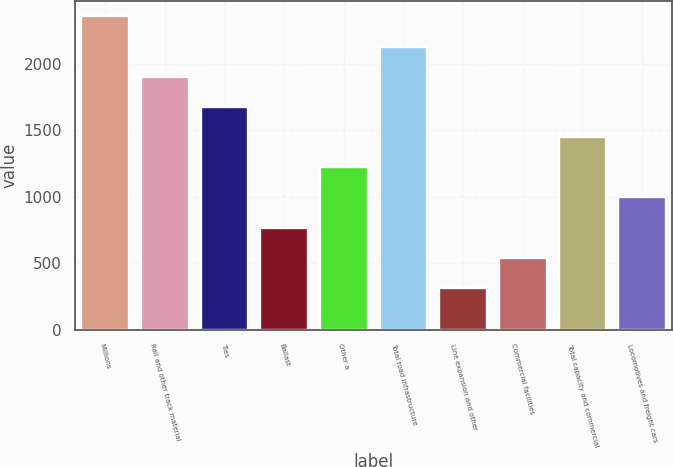Convert chart. <chart><loc_0><loc_0><loc_500><loc_500><bar_chart><fcel>Millions<fcel>Rail and other track material<fcel>Ties<fcel>Ballast<fcel>Other a<fcel>Total road infrastructure<fcel>Line expansion and other<fcel>Commercial facilities<fcel>Total capacity and commercial<fcel>Locomotives and freight cars<nl><fcel>2354<fcel>1901.2<fcel>1674.8<fcel>769.2<fcel>1222<fcel>2127.6<fcel>316.4<fcel>542.8<fcel>1448.4<fcel>995.6<nl></chart> 